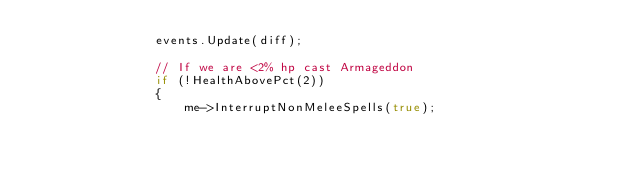<code> <loc_0><loc_0><loc_500><loc_500><_C++_>                events.Update(diff);

                // If we are <2% hp cast Armageddon
                if (!HealthAbovePct(2))
                {
                    me->InterruptNonMeleeSpells(true);</code> 